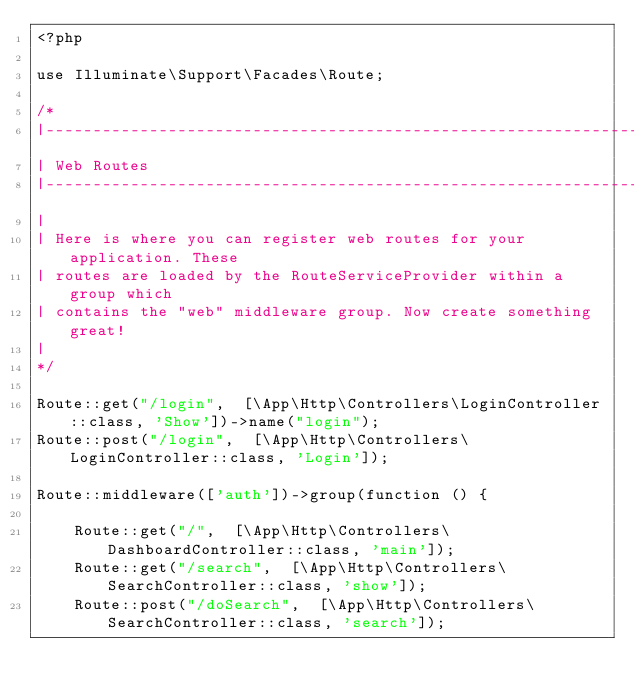<code> <loc_0><loc_0><loc_500><loc_500><_PHP_><?php

use Illuminate\Support\Facades\Route;

/*
|--------------------------------------------------------------------------
| Web Routes
|--------------------------------------------------------------------------
|
| Here is where you can register web routes for your application. These
| routes are loaded by the RouteServiceProvider within a group which
| contains the "web" middleware group. Now create something great!
|
*/

Route::get("/login",  [\App\Http\Controllers\LoginController::class, 'Show'])->name("login");
Route::post("/login",  [\App\Http\Controllers\LoginController::class, 'Login']);

Route::middleware(['auth'])->group(function () {

    Route::get("/",  [\App\Http\Controllers\DashboardController::class, 'main']);
    Route::get("/search",  [\App\Http\Controllers\SearchController::class, 'show']);
    Route::post("/doSearch",  [\App\Http\Controllers\SearchController::class, 'search']);</code> 